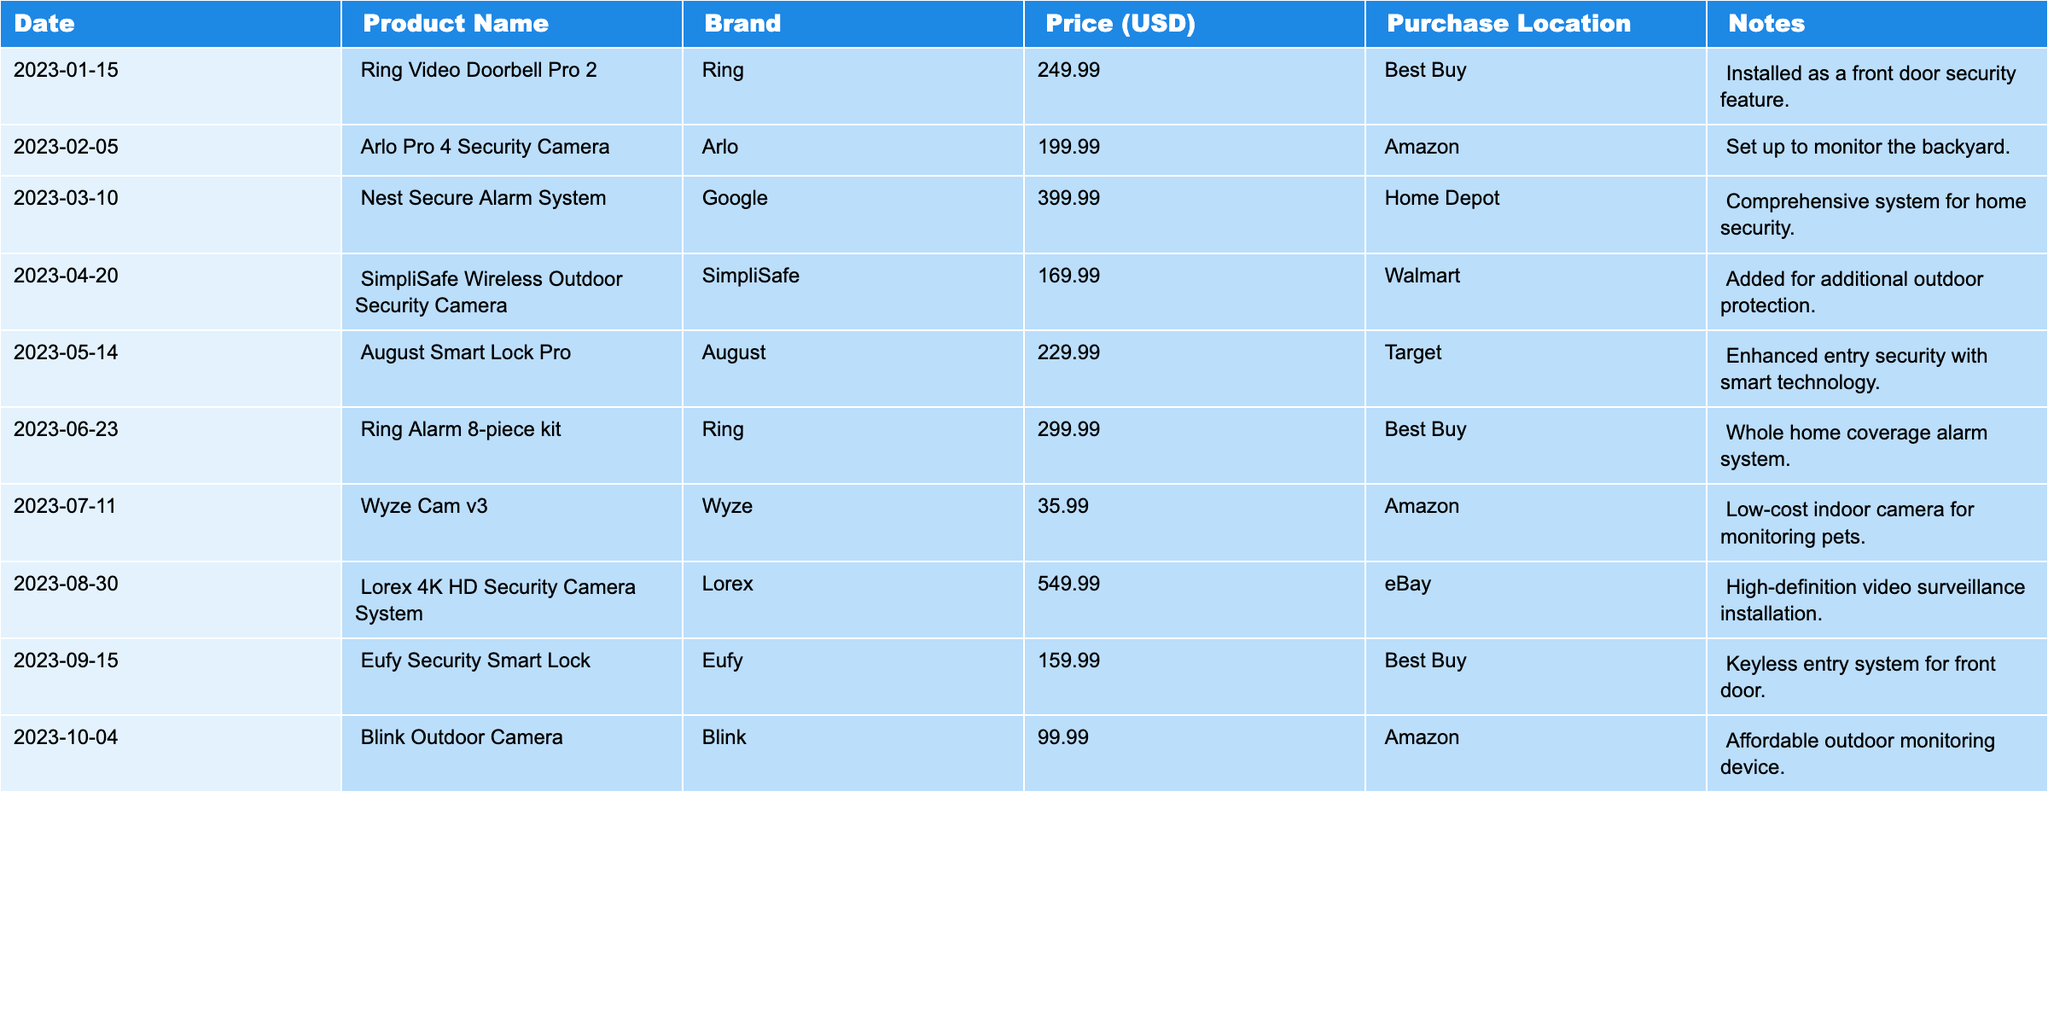What is the most expensive item purchased? By looking at the "Price (USD)" column in the table, the highest price listed is $549.99, which corresponds to the "Lorex 4K HD Security Camera System."
Answer: Lorex 4K HD Security Camera System Which brand has the highest number of purchases? Counting the entries for each brand in the table, Ring and Arlo each have two purchases, while other brands have one or none. Thus, Ring and Arlo tie for the highest number of purchases.
Answer: Ring and Arlo What is the total amount spent on security systems? To find the total, we sum the prices: 249.99 + 199.99 + 399.99 + 169.99 + 229.99 + 299.99 + 35.99 + 549.99 + 159.99 + 99.99 = 1,784.90.
Answer: 1784.90 Was there any purchase made at Home Depot? Yes, the "Nest Secure Alarm System" was purchased at Home Depot on March 10.
Answer: True What is the average price of the items purchased from Amazon? The prices from Amazon are 199.99 (Arlo Pro 4) and 35.99 (Wyze Cam v3). The average is (199.99 + 35.99) / 2 = 117.99.
Answer: 117.99 How many items were purchased for outdoor security? The items specifically for outdoor security are the "Arlo Pro 4 Security Camera," "SimpliSafe Wireless Outdoor Security Camera," and "Blink Outdoor Camera," totaling three items.
Answer: 3 What was the least expensive item and what was it used for? The least expensive item is "Wyze Cam v3," priced at $35.99, which is used for monitoring pets indoors.
Answer: Wyze Cam v3, monitoring pets Did any of the purchases include a smart lock? Yes, there were two purchases that included smart locks: "August Smart Lock Pro" and "Eufy Security Smart Lock."
Answer: True What percentage of the total expenditure was spent on the "Nest Secure Alarm System"? The price of the "Nest Secure Alarm System" is $399.99. To find the percentage, calculate (399.99 / 1784.90) * 100, which equals approximately 22.4%.
Answer: 22.4% How many purchases were made in the summer months (June, July, August)? The purchases in summer are: "Ring Alarm 8-piece kit" (June), "Wyze Cam v3" (July), and "Lorex 4K HD Security Camera System" (August), totaling three purchases.
Answer: 3 